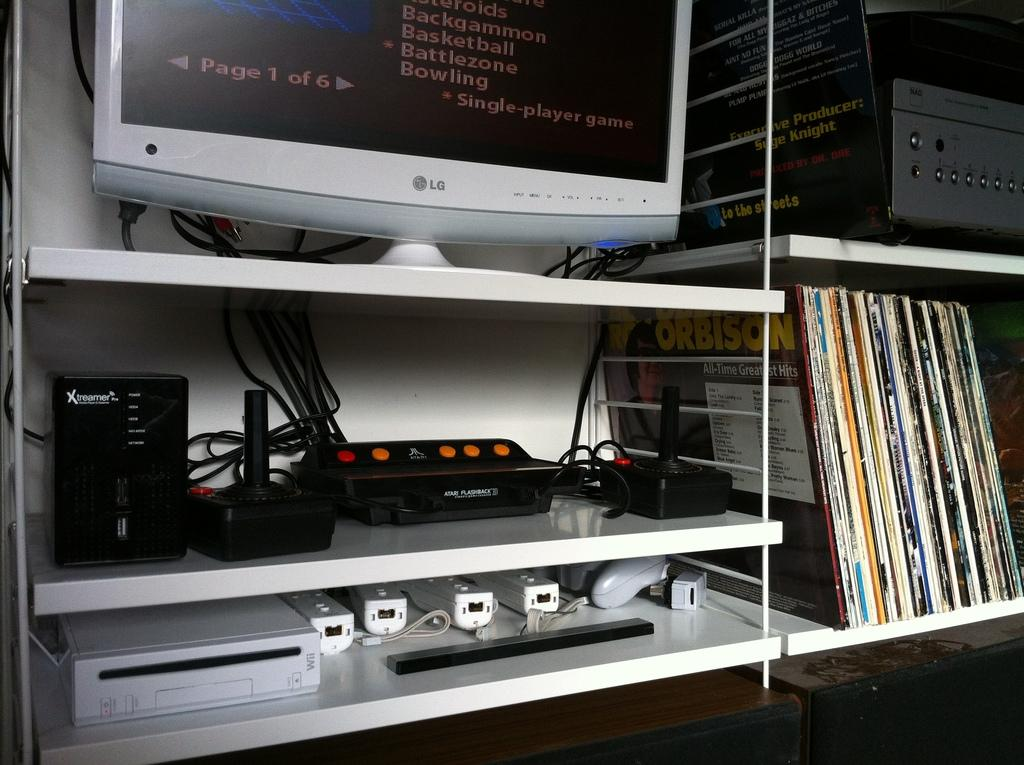<image>
Present a compact description of the photo's key features. A computer sitting on a shelf with an atari system below it. 